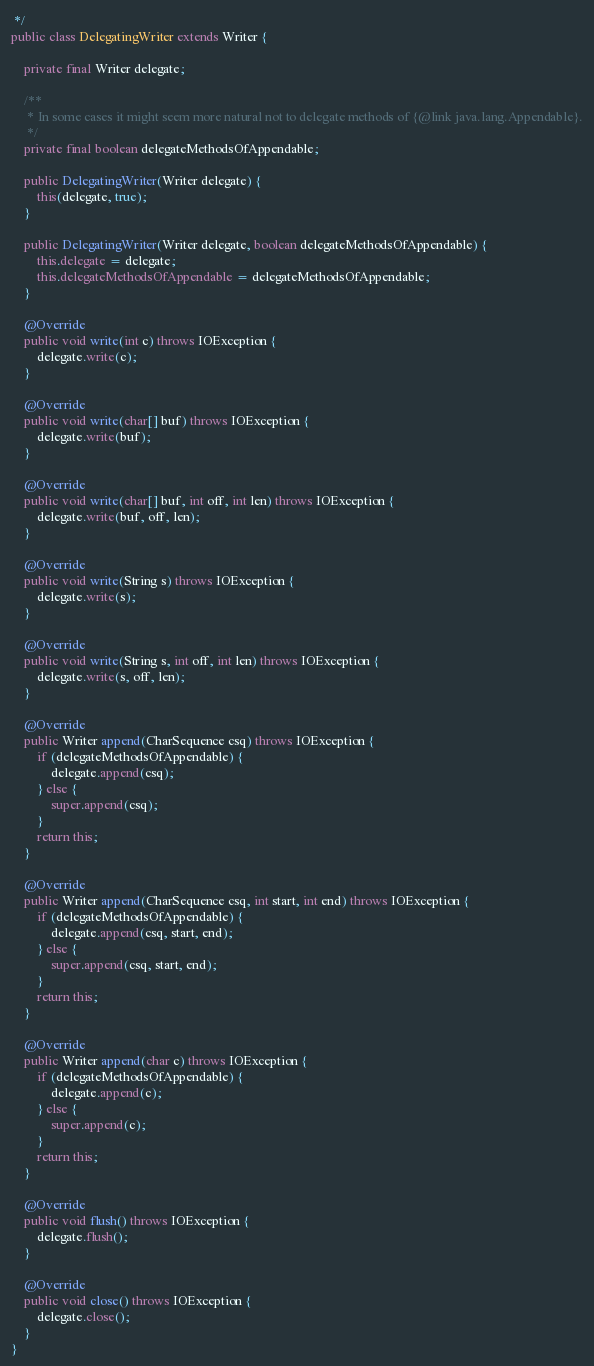Convert code to text. <code><loc_0><loc_0><loc_500><loc_500><_Java_> */
public class DelegatingWriter extends Writer {

    private final Writer delegate;

    /**
     * In some cases it might seem more natural not to delegate methods of {@link java.lang.Appendable}.
     */
    private final boolean delegateMethodsOfAppendable;

    public DelegatingWriter(Writer delegate) {
        this(delegate, true);
    }

    public DelegatingWriter(Writer delegate, boolean delegateMethodsOfAppendable) {
        this.delegate = delegate;
        this.delegateMethodsOfAppendable = delegateMethodsOfAppendable;
    }

    @Override
    public void write(int c) throws IOException {
        delegate.write(c);
    }

    @Override
    public void write(char[] buf) throws IOException {
        delegate.write(buf);
    }

    @Override
    public void write(char[] buf, int off, int len) throws IOException {
        delegate.write(buf, off, len);
    }

    @Override
    public void write(String s) throws IOException {
        delegate.write(s);
    }

    @Override
    public void write(String s, int off, int len) throws IOException {
        delegate.write(s, off, len);
    }

    @Override
    public Writer append(CharSequence csq) throws IOException {
        if (delegateMethodsOfAppendable) {
            delegate.append(csq);
        } else {
            super.append(csq);
        }
        return this;
    }

    @Override
    public Writer append(CharSequence csq, int start, int end) throws IOException {
        if (delegateMethodsOfAppendable) {
            delegate.append(csq, start, end);
        } else {
            super.append(csq, start, end);
        }
        return this;
    }

    @Override
    public Writer append(char c) throws IOException {
        if (delegateMethodsOfAppendable) {
            delegate.append(c);
        } else {
            super.append(c);
        }
        return this;
    }

    @Override
    public void flush() throws IOException {
        delegate.flush();
    }

    @Override
    public void close() throws IOException {
        delegate.close();
    }
}
</code> 